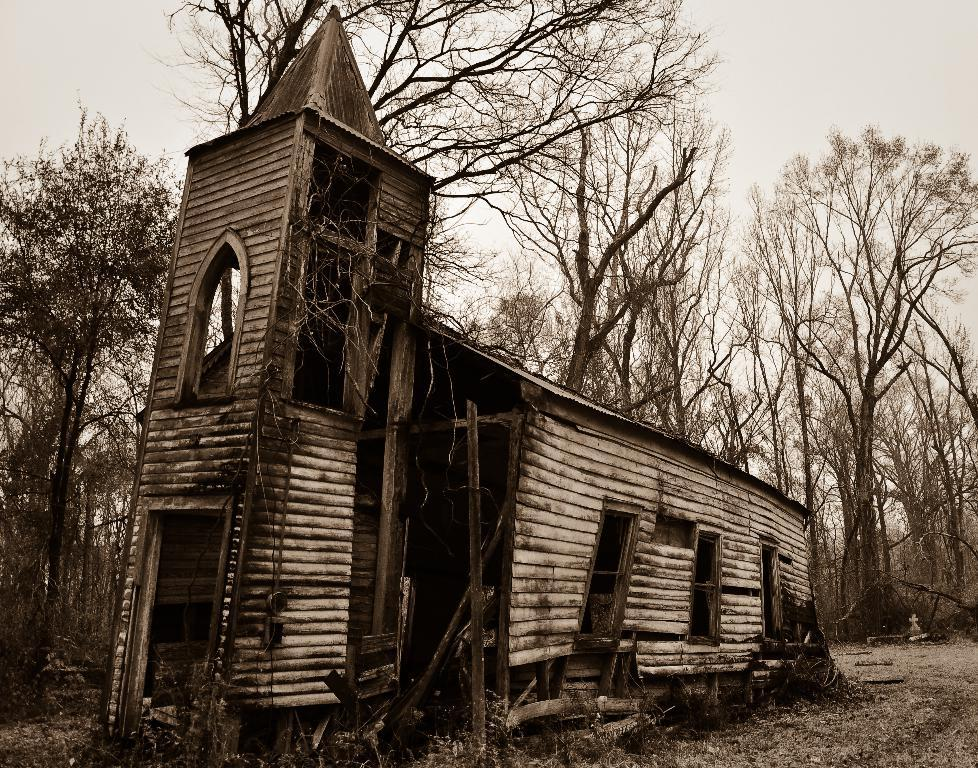What type of building is in the image? There is a wooden building in the image. What can be seen in the background of the image? There are many trees, plants, and grass in the background of the image. What is visible at the top of the image? The sky is visible at the top of the image. What can be observed in the sky? Clouds are present in the sky. What type of wax is being used by the maid in the image? There is no maid or wax present in the image. 